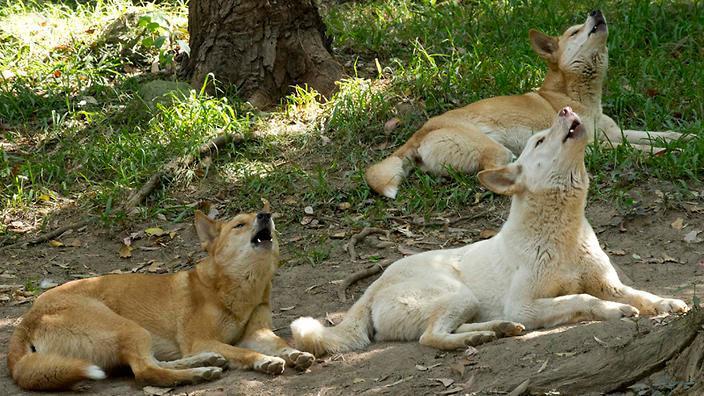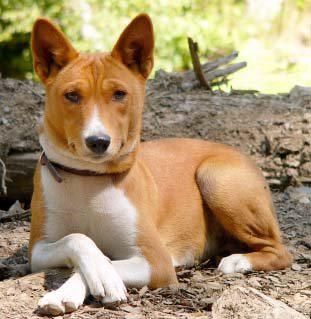The first image is the image on the left, the second image is the image on the right. Examine the images to the left and right. Is the description "There are multiple canine laying down with there feet in front of them." accurate? Answer yes or no. Yes. 